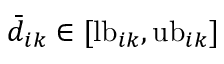Convert formula to latex. <formula><loc_0><loc_0><loc_500><loc_500>\bar { d } _ { i k } \in [ l b _ { i k } , u b _ { i k } ]</formula> 